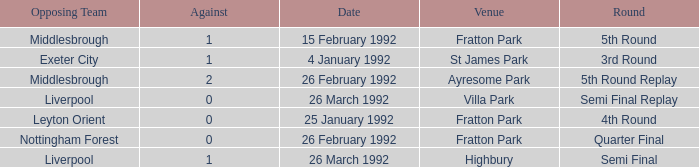What was the round for Villa Park? Semi Final Replay. 